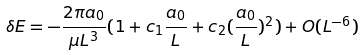Convert formula to latex. <formula><loc_0><loc_0><loc_500><loc_500>\delta E = - \frac { 2 \pi a _ { 0 } } { \mu L ^ { 3 } } ( 1 + c _ { 1 } \frac { a _ { 0 } } { L } + c _ { 2 } ( \frac { a _ { 0 } } { L } ) ^ { 2 } ) + O ( L ^ { - 6 } )</formula> 